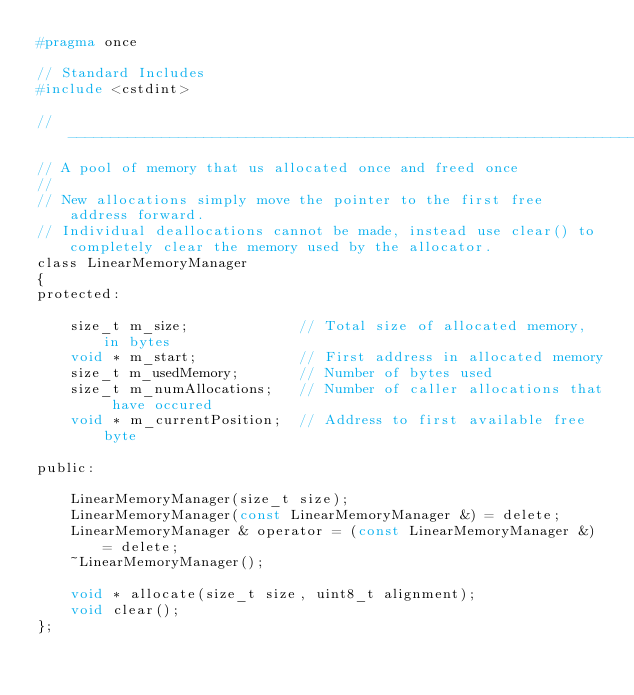<code> <loc_0><loc_0><loc_500><loc_500><_C_>#pragma once

// Standard Includes
#include <cstdint>

//------------------------------------------------------------------------------
// A pool of memory that us allocated once and freed once
//
// New allocations simply move the pointer to the first free address forward.
// Individual deallocations cannot be made, instead use clear() to completely clear the memory used by the allocator.
class LinearMemoryManager
{
protected:

    size_t m_size;             // Total size of allocated memory, in bytes
    void * m_start;            // First address in allocated memory
    size_t m_usedMemory;       // Number of bytes used
    size_t m_numAllocations;   // Number of caller allocations that have occured
    void * m_currentPosition;  // Address to first available free byte

public:

    LinearMemoryManager(size_t size);
    LinearMemoryManager(const LinearMemoryManager &) = delete;
    LinearMemoryManager & operator = (const LinearMemoryManager &) = delete;
    ~LinearMemoryManager();

    void * allocate(size_t size, uint8_t alignment);
    void clear();
};

</code> 